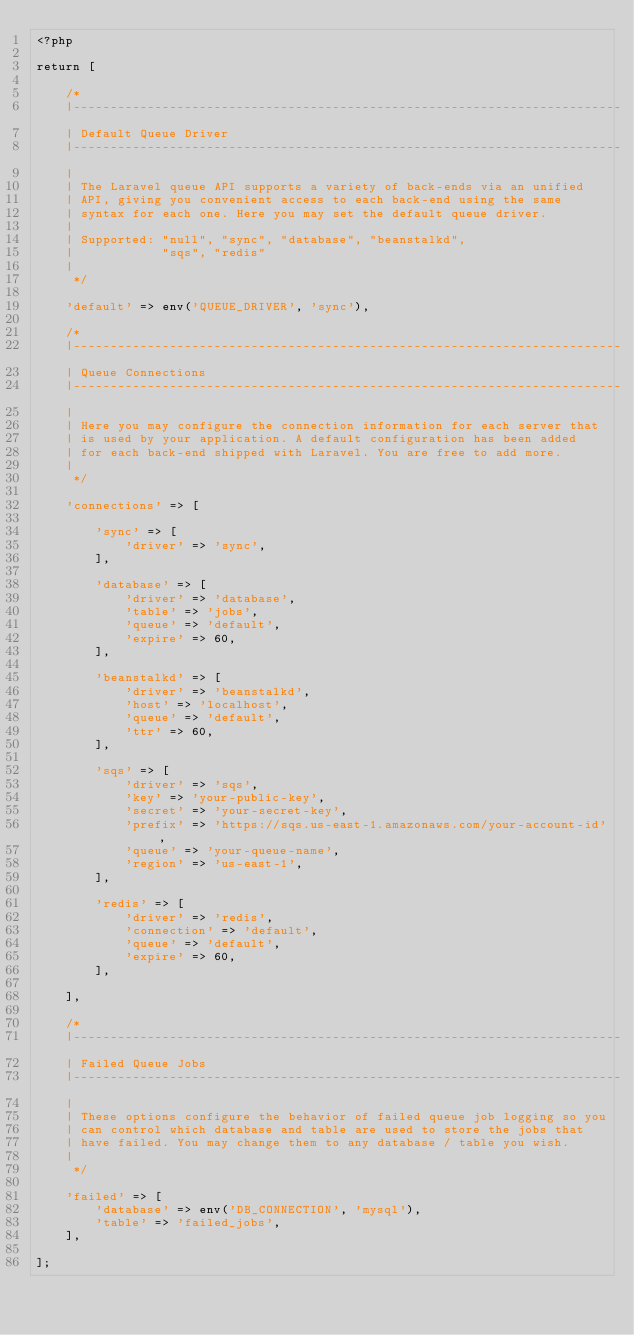<code> <loc_0><loc_0><loc_500><loc_500><_PHP_><?php

return [

    /*
    |--------------------------------------------------------------------------
    | Default Queue Driver
    |--------------------------------------------------------------------------
    |
    | The Laravel queue API supports a variety of back-ends via an unified
    | API, giving you convenient access to each back-end using the same
    | syntax for each one. Here you may set the default queue driver.
    |
    | Supported: "null", "sync", "database", "beanstalkd",
    |            "sqs", "redis"
    |
     */

    'default' => env('QUEUE_DRIVER', 'sync'),

    /*
    |--------------------------------------------------------------------------
    | Queue Connections
    |--------------------------------------------------------------------------
    |
    | Here you may configure the connection information for each server that
    | is used by your application. A default configuration has been added
    | for each back-end shipped with Laravel. You are free to add more.
    |
     */

    'connections' => [

        'sync' => [
            'driver' => 'sync',
        ],

        'database' => [
            'driver' => 'database',
            'table' => 'jobs',
            'queue' => 'default',
            'expire' => 60,
        ],

        'beanstalkd' => [
            'driver' => 'beanstalkd',
            'host' => 'localhost',
            'queue' => 'default',
            'ttr' => 60,
        ],

        'sqs' => [
            'driver' => 'sqs',
            'key' => 'your-public-key',
            'secret' => 'your-secret-key',
            'prefix' => 'https://sqs.us-east-1.amazonaws.com/your-account-id',
            'queue' => 'your-queue-name',
            'region' => 'us-east-1',
        ],

        'redis' => [
            'driver' => 'redis',
            'connection' => 'default',
            'queue' => 'default',
            'expire' => 60,
        ],

    ],

    /*
    |--------------------------------------------------------------------------
    | Failed Queue Jobs
    |--------------------------------------------------------------------------
    |
    | These options configure the behavior of failed queue job logging so you
    | can control which database and table are used to store the jobs that
    | have failed. You may change them to any database / table you wish.
    |
     */

    'failed' => [
        'database' => env('DB_CONNECTION', 'mysql'),
        'table' => 'failed_jobs',
    ],

];
</code> 